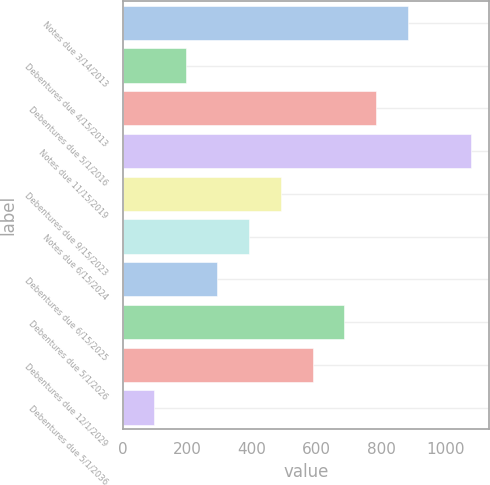Convert chart to OTSL. <chart><loc_0><loc_0><loc_500><loc_500><bar_chart><fcel>Notes due 3/14/2013<fcel>Debentures due 4/15/2013<fcel>Debentures due 5/1/2016<fcel>Notes due 11/15/2019<fcel>Debentures due 9/15/2023<fcel>Notes due 6/15/2024<fcel>Debentures due 6/15/2025<fcel>Debentures due 5/1/2026<fcel>Debentures due 12/1/2029<fcel>Debentures due 5/1/2036<nl><fcel>882.6<fcel>195.2<fcel>784.4<fcel>1079<fcel>489.8<fcel>391.6<fcel>293.4<fcel>686.2<fcel>588<fcel>97<nl></chart> 